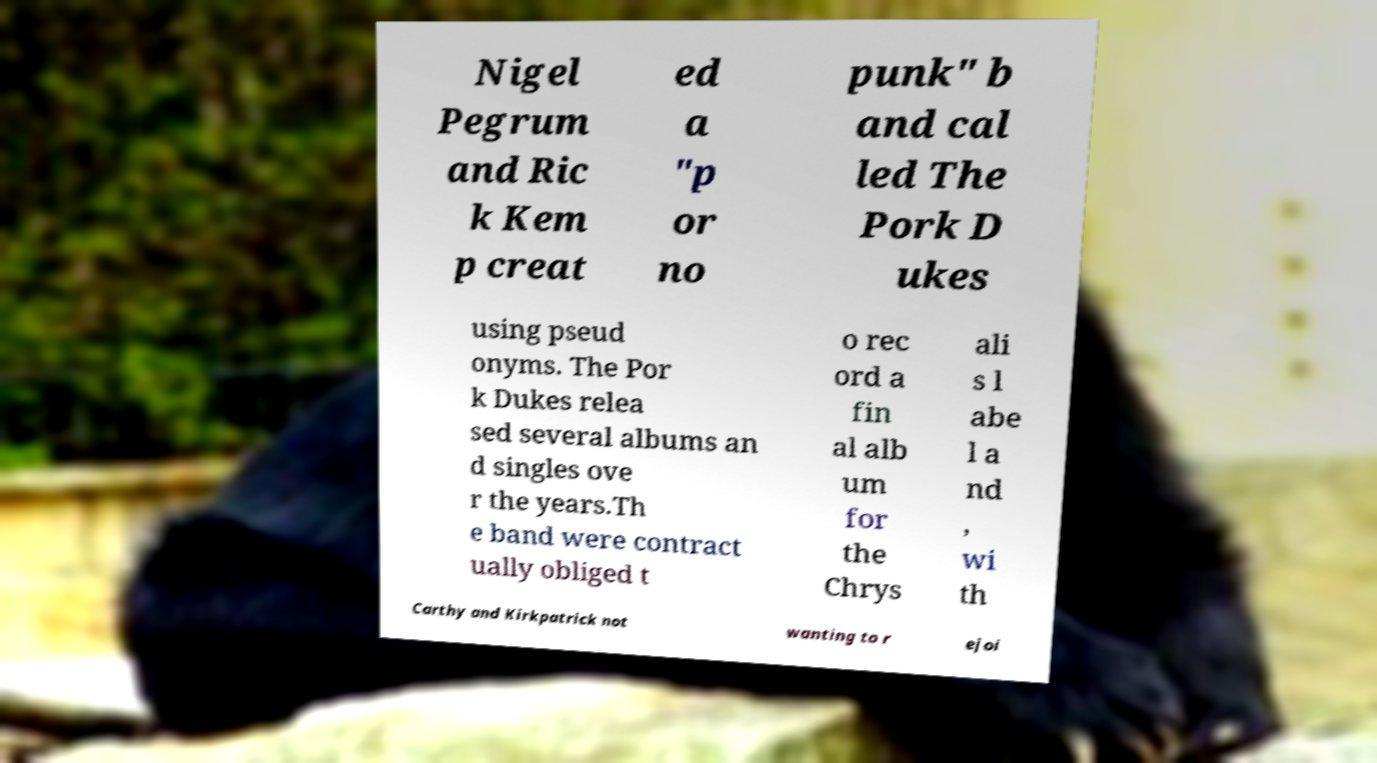What messages or text are displayed in this image? I need them in a readable, typed format. Nigel Pegrum and Ric k Kem p creat ed a "p or no punk" b and cal led The Pork D ukes using pseud onyms. The Por k Dukes relea sed several albums an d singles ove r the years.Th e band were contract ually obliged t o rec ord a fin al alb um for the Chrys ali s l abe l a nd , wi th Carthy and Kirkpatrick not wanting to r ejoi 